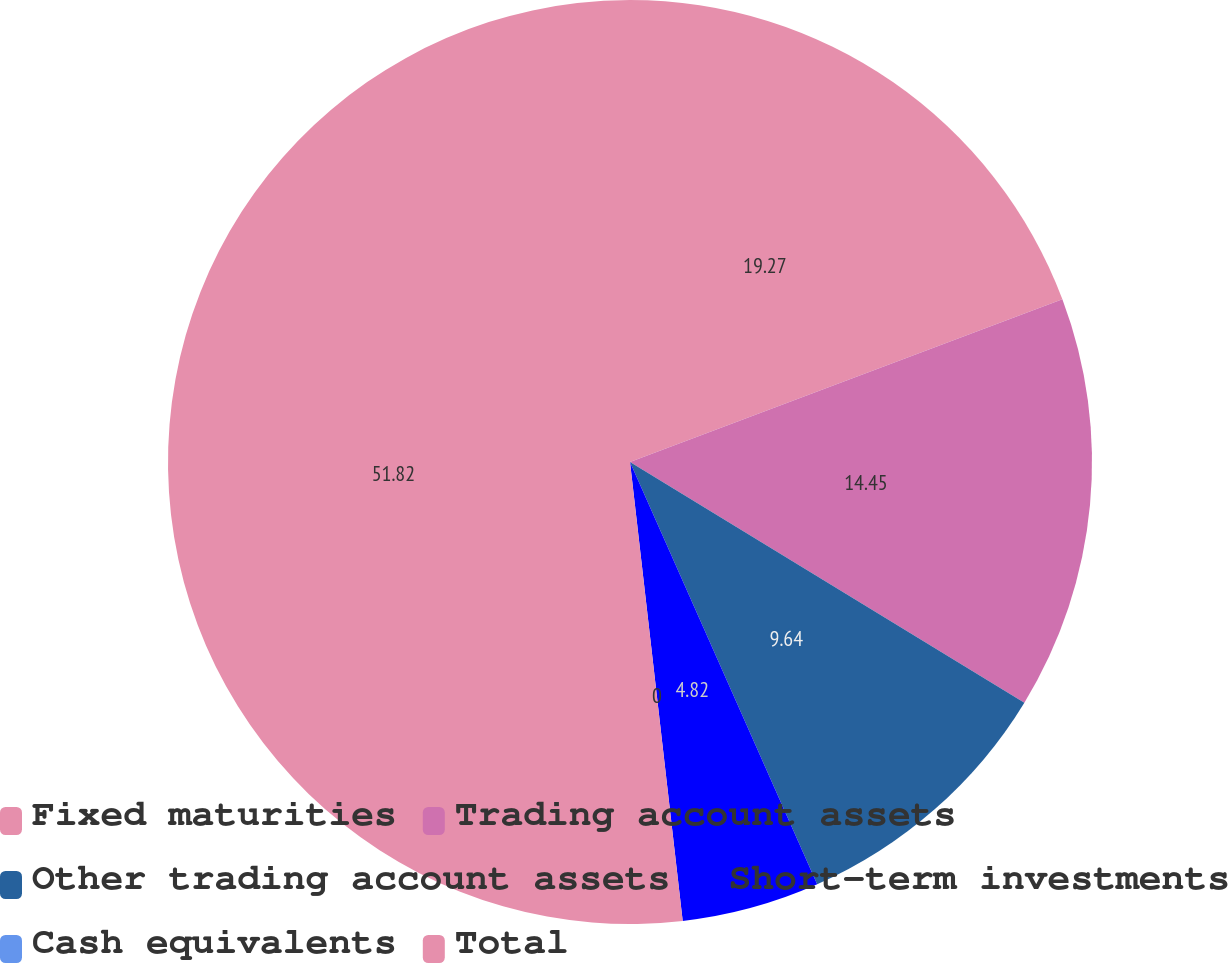Convert chart to OTSL. <chart><loc_0><loc_0><loc_500><loc_500><pie_chart><fcel>Fixed maturities<fcel>Trading account assets<fcel>Other trading account assets<fcel>Short-term investments<fcel>Cash equivalents<fcel>Total<nl><fcel>19.27%<fcel>14.45%<fcel>9.64%<fcel>4.82%<fcel>0.0%<fcel>51.82%<nl></chart> 